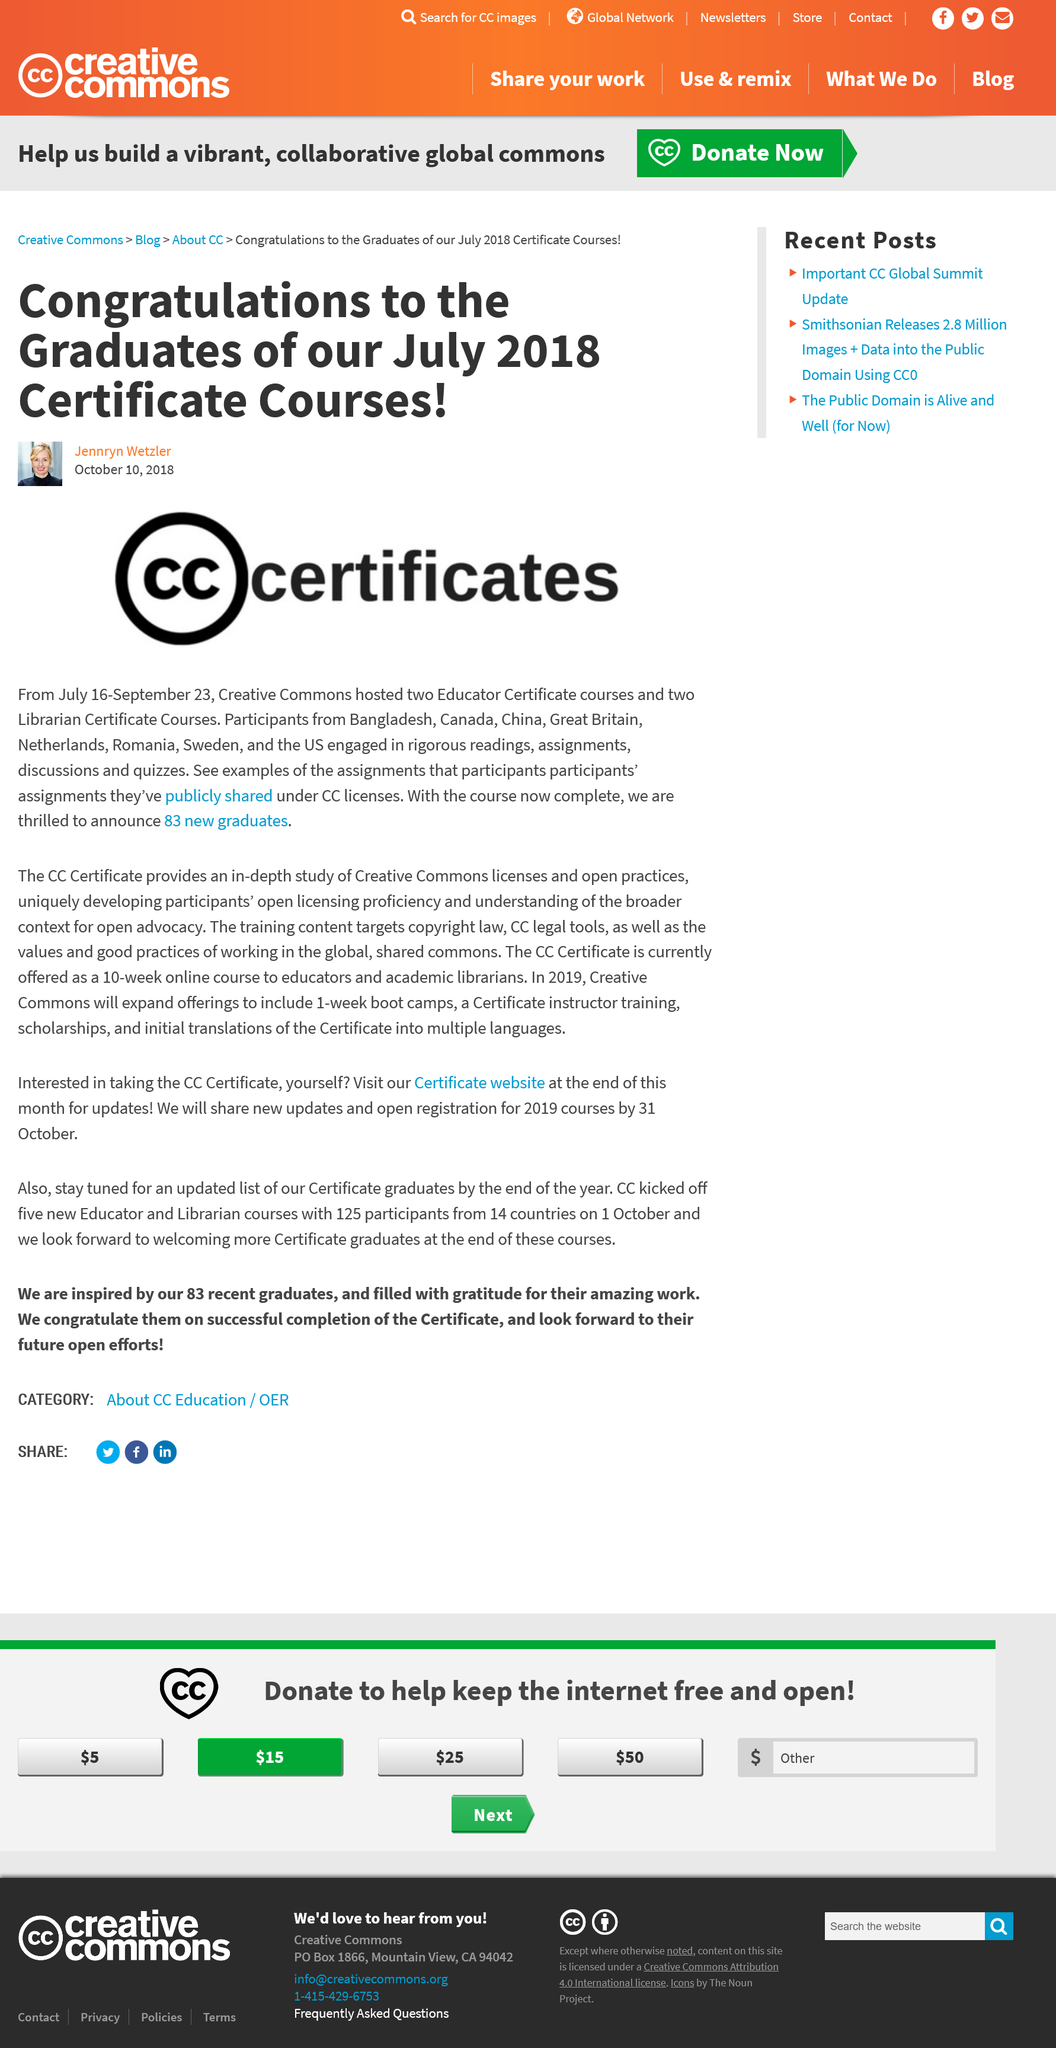Indicate a few pertinent items in this graphic. During the period of July 16th through September 23rd in 2018, Creative Commons hosted two Educator Certificate courses and two Librarian Certificate courses. In 2018, graduates from Bangladesh, Canada, China, Great Britain, the Netherlands, Romania, Sweden, and the US participated in Creative Commons courses. In July 2018, a total of 83 individuals completed the Creative Commons certificate courses. 